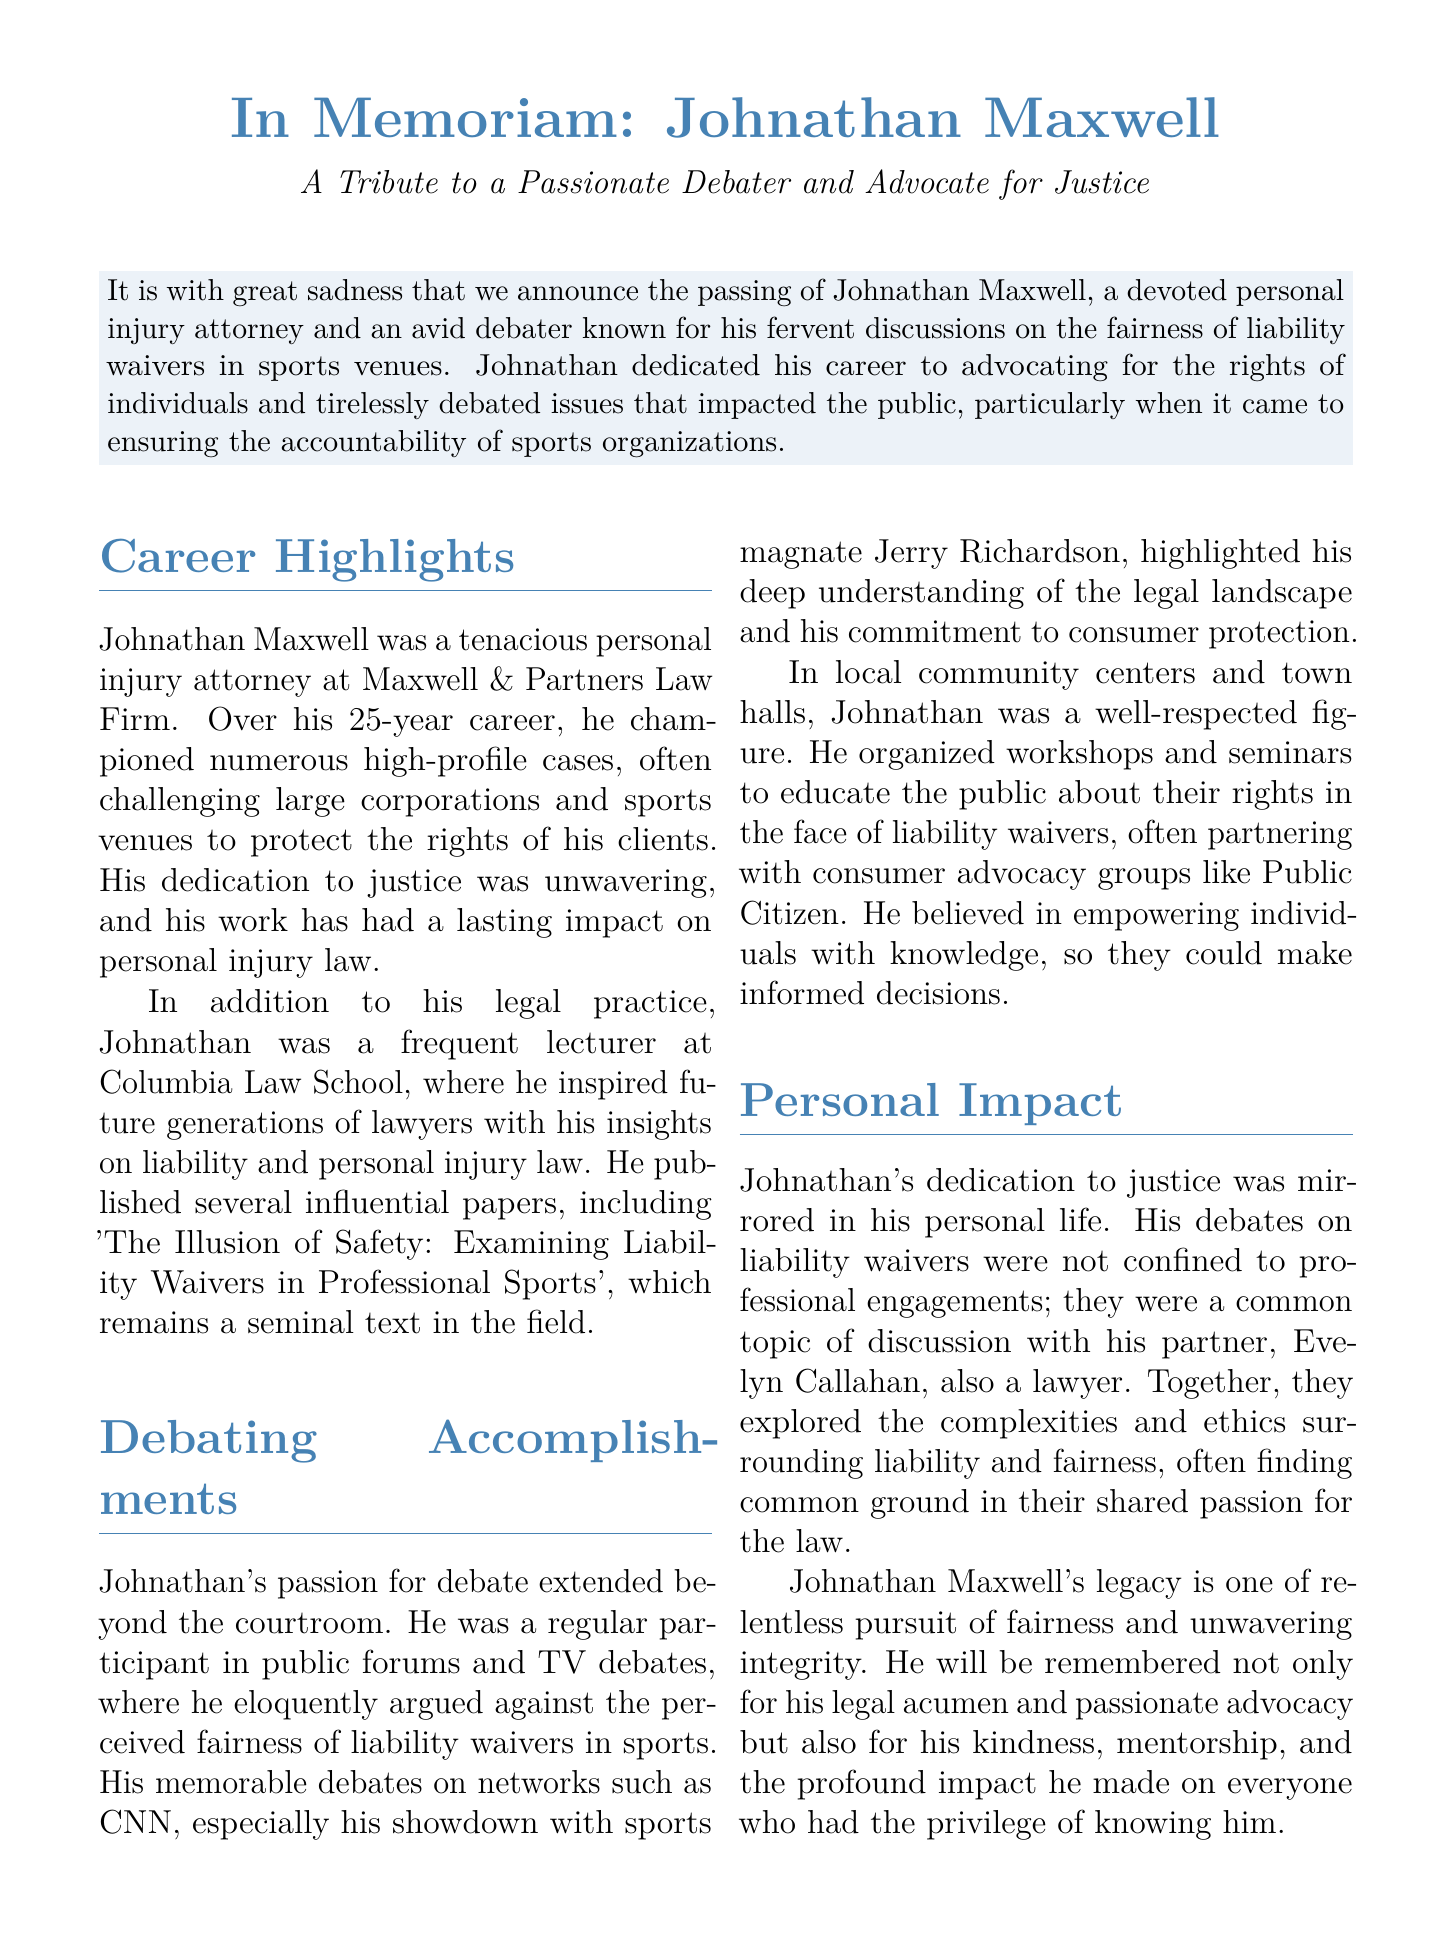What was Johnathan Maxwell's profession? Johnathan Maxwell was a personal injury attorney, as stated in the document.
Answer: personal injury attorney How many years did Johnathan Maxwell practice law? The document states that he practiced for 25 years.
Answer: 25 years What was the title of one of Johnathan Maxwell's influential papers? One of his papers is titled 'The Illusion of Safety: Examining Liability Waivers in Professional Sports'.
Answer: The Illusion of Safety: Examining Liability Waivers in Professional Sports With which law school did Johnathan Maxwell have a lecturing relationship? The document mentions that he was a lecturer at Columbia Law School.
Answer: Columbia Law School Who was Johnathan Maxwell's partner? His partner is named Evelyn Callahan, as mentioned in the document.
Answer: Evelyn Callahan What organization did Johnathan Maxwell partner with for workshops? He partnered with a consumer advocacy group called Public Citizen.
Answer: Public Citizen What is a key aspect of Johnathan Maxwell’s legacy? The document highlights that he is remembered for his relentless pursuit of fairness and unwavering integrity.
Answer: relentless pursuit of fairness In which public forum did Johnathan Maxwell debate sports magnate Jerry Richardson? He debated Jerry Richardson on networks such as CNN.
Answer: CNN What did Johnathan Maxwell believe in empowering individuals with? He believed in empowering individuals with knowledge regarding their rights.
Answer: knowledge 